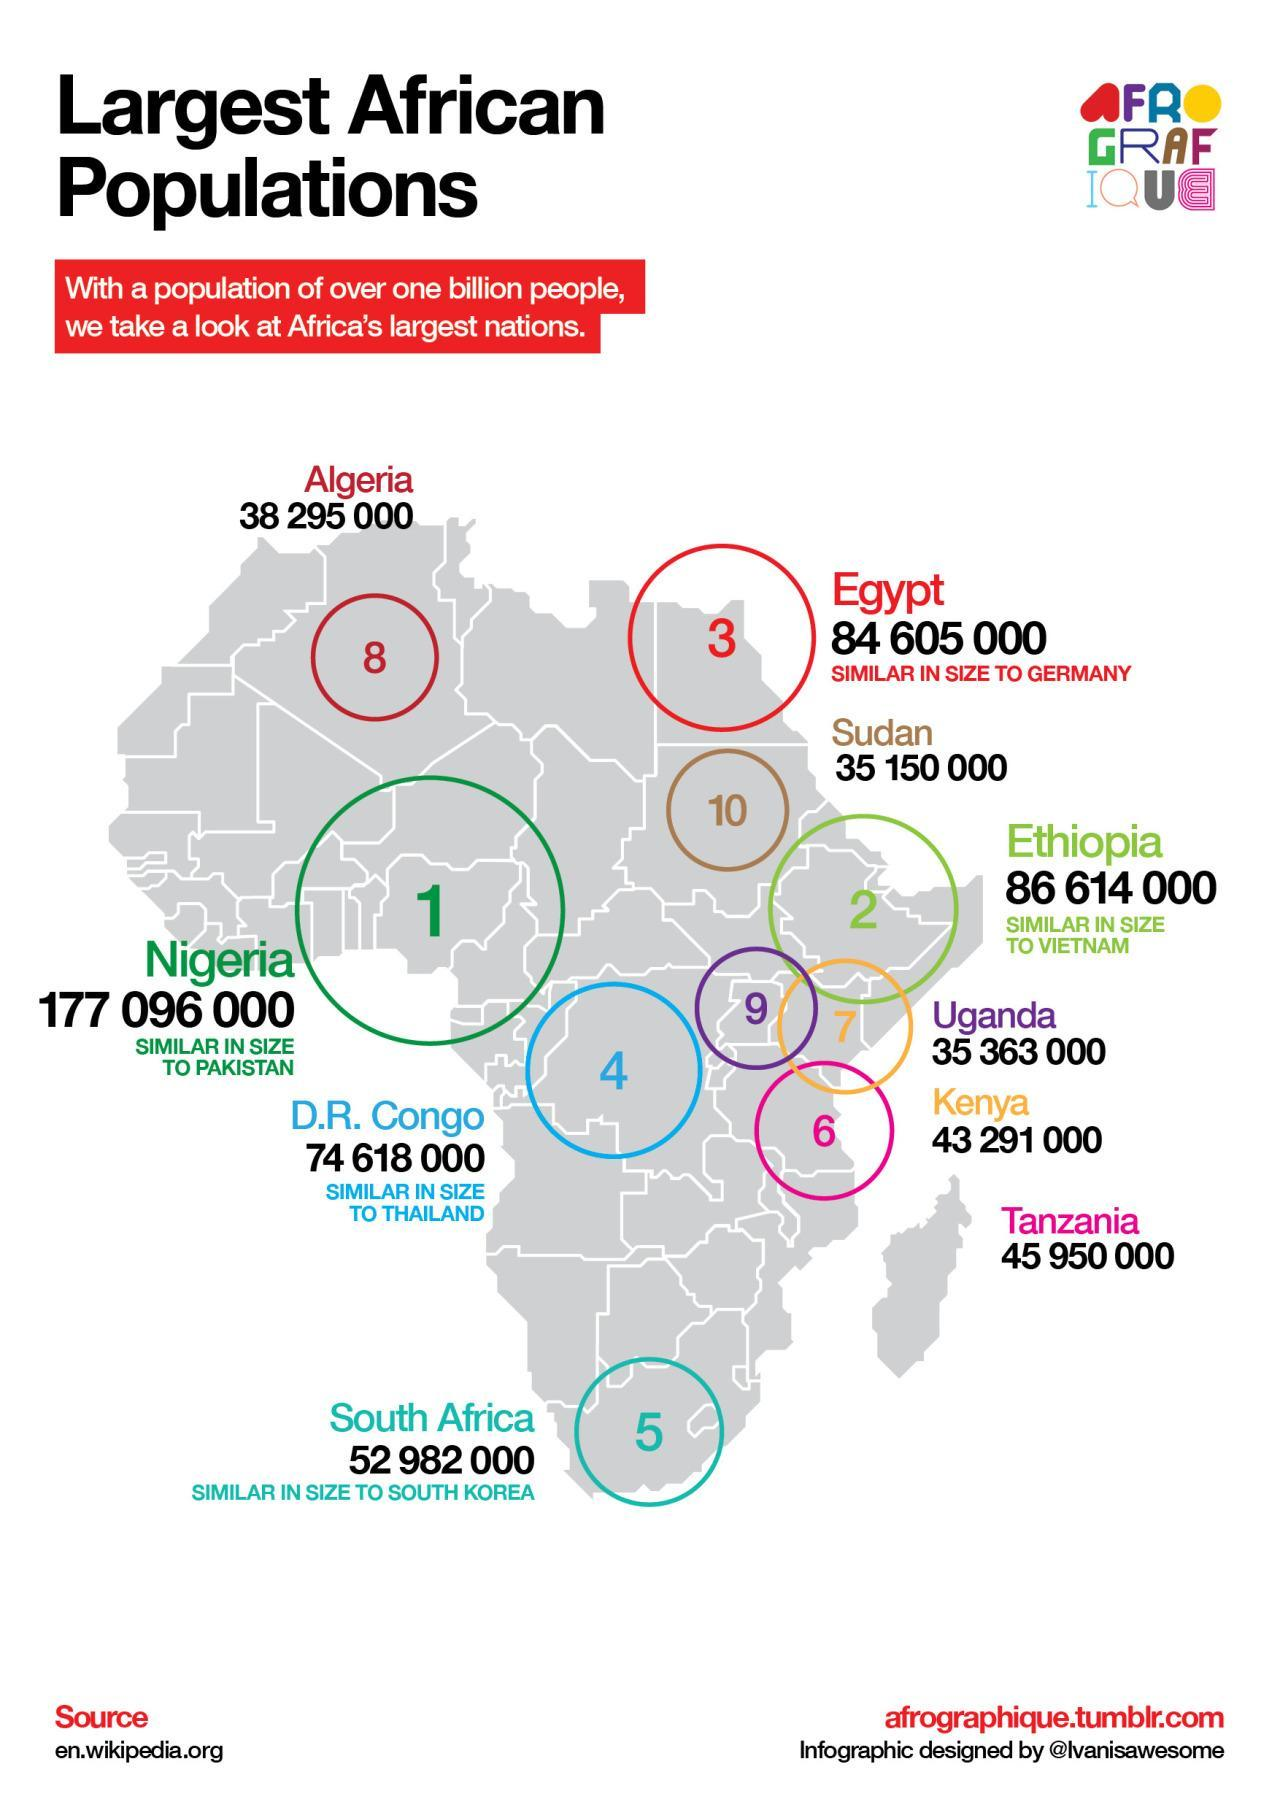which country has the ninth largest population in Africa?
Answer the question with a short phrase. Uganda population of which country is higher - Uganda or Kenya? Kenya population of which country is higher - Nigeria or Ethiopia? Nigeria what is the total population of Sudan and Egypt taken together? 119755000 what is the population of the country with 7th largest population in Africa? 43291000 which are the three African countries of largest population? Nigeria, Ethiopia, Egypt what is the total population of Uganda and Kenya taken together? 78654000 what is the population of the country with 6th largest population in Africa? 45950000 what is the total population of South Africa and Tanzania taken together? 98932000 which country has the 6th largest population in Africa? Tanzania population  of which country is higher - Egypt or D. R. Congo Egypt population of which country is smaller - Kenya or South Africa? Kenya which country has the second largest population in Africa? Ethiopia what is the population of the country with largest population in Africa? 177096000 what is the total population of 9th largest and 10th largest population in Africa  taken together? 70513000 